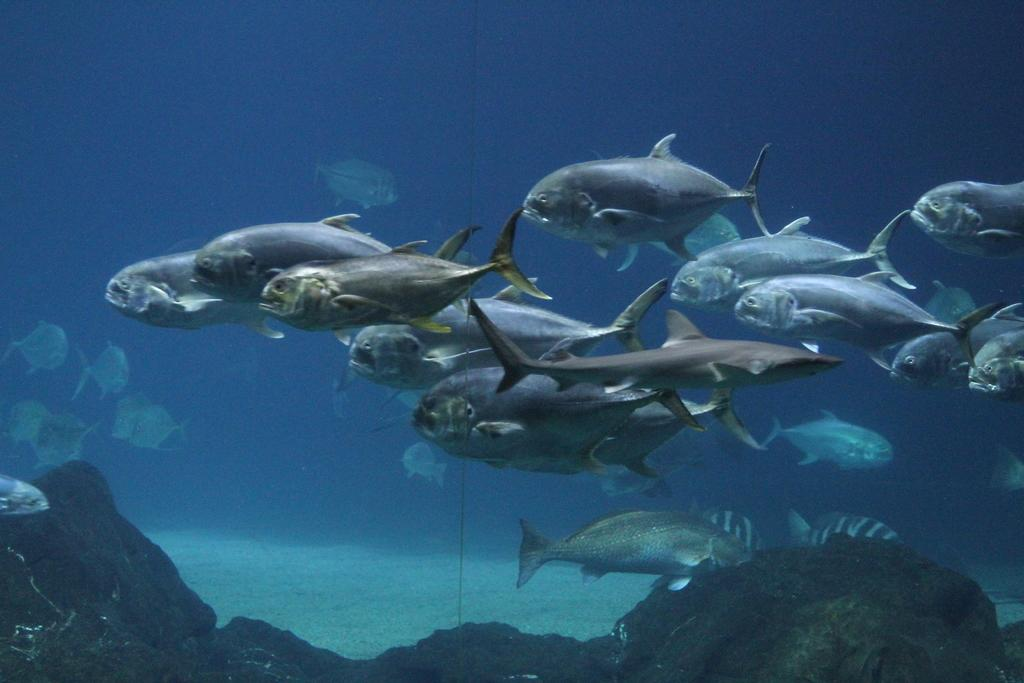What type of animals can be seen in the image? There are fishes in the image. What else is present in the image besides the fishes? There are rocks in the image. Can you describe the setting in which the fishes and rocks are located? The image appears to be of an aquarium. What type of cart is visible in the image? There is no cart present in the image; it features an aquarium with fishes and rocks. 